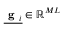Convert formula to latex. <formula><loc_0><loc_0><loc_500><loc_500>\underline { { g _ { i } } } \in \mathbb { R } ^ { M L }</formula> 